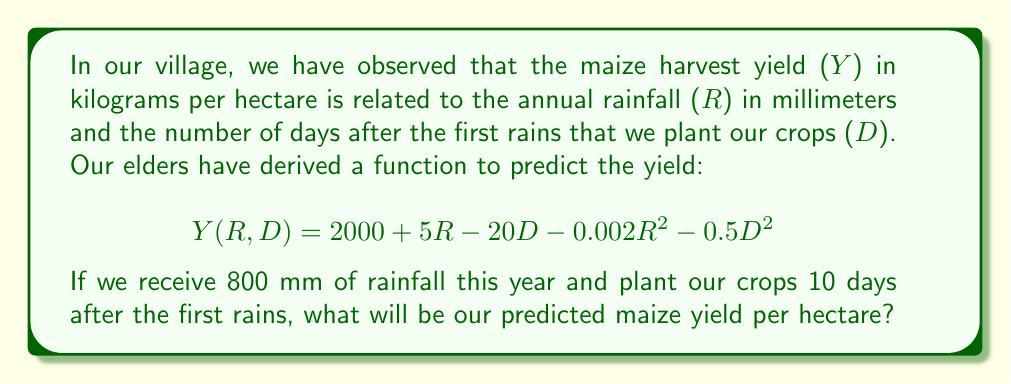What is the answer to this math problem? To solve this problem, we need to follow these steps:

1. Identify the given values:
   $R = 800$ mm (annual rainfall)
   $D = 10$ days (planting delay)

2. Substitute these values into the yield function:
   $$Y(800, 10) = 2000 + 5(800) - 20(10) - 0.002(800)^2 - 0.5(10)^2$$

3. Simplify the expression:
   $$Y(800, 10) = 2000 + 4000 - 200 - 0.002(640000) - 0.5(100)$$
   $$Y(800, 10) = 2000 + 4000 - 200 - 1280 - 50$$

4. Perform the arithmetic:
   $$Y(800, 10) = 6000 - 200 - 1280 - 50$$
   $$Y(800, 10) = 4470$$

Therefore, the predicted maize yield per hectare is 4470 kg.
Answer: 4470 kg/ha 